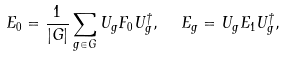Convert formula to latex. <formula><loc_0><loc_0><loc_500><loc_500>E _ { 0 } = \frac { 1 } { | G | } \sum _ { g \in G } U _ { g } F _ { 0 } U _ { g } ^ { \dagger } , \ \ E _ { g } = U _ { g } E _ { 1 } U _ { g } ^ { \dagger } ,</formula> 